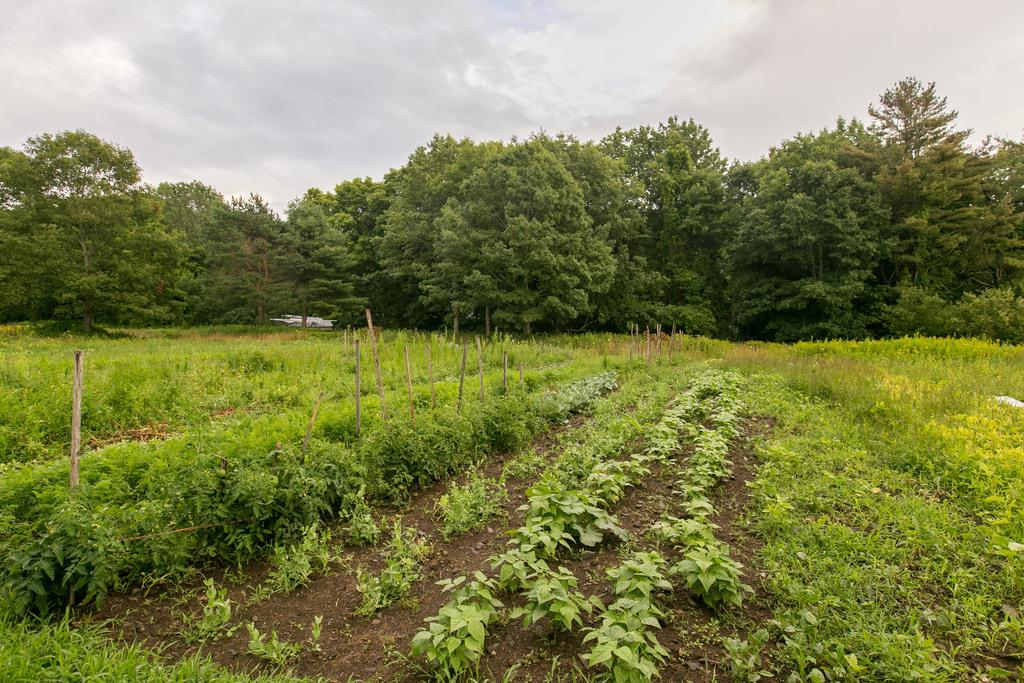What type of vegetation can be seen in the image? There are plants and trees in the image. What type of terrain is visible in the image? There is sand in the image. What objects are made of wood in the image? There are wooden sticks in the image. What can be seen in the background of the image? The sky is visible in the background of the image. What is the governor's opinion on the board in the image? There is no governor or board present in the image. How many fifths are visible in the image? The concept of "fifths" is not applicable to the image, as it does not involve fractions or divisions. 